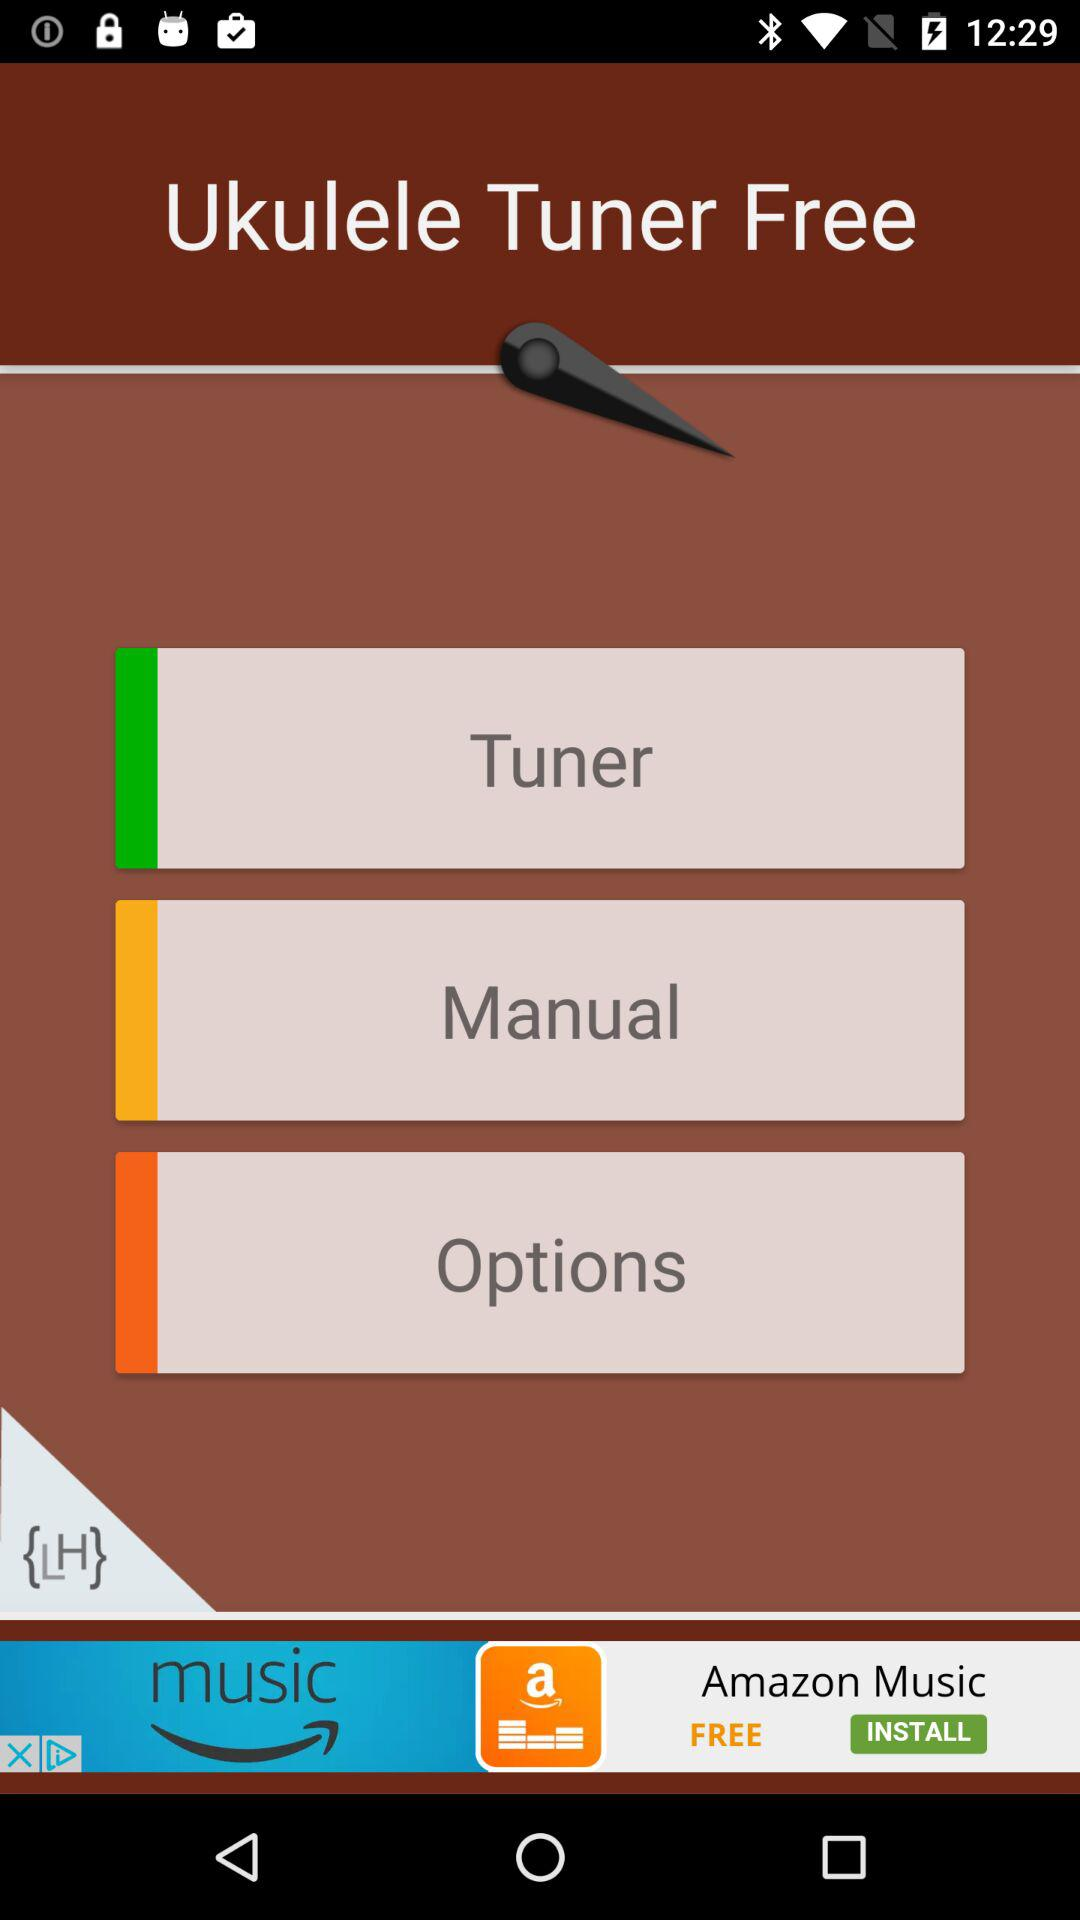What is the name of the application? The name of the application is "Ukulele Tuner Free". 